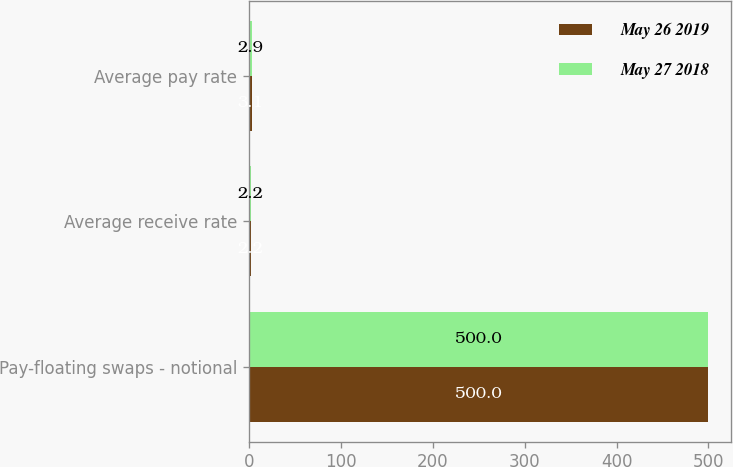Convert chart to OTSL. <chart><loc_0><loc_0><loc_500><loc_500><stacked_bar_chart><ecel><fcel>Pay-floating swaps - notional<fcel>Average receive rate<fcel>Average pay rate<nl><fcel>May 26 2019<fcel>500<fcel>2.2<fcel>3.1<nl><fcel>May 27 2018<fcel>500<fcel>2.2<fcel>2.9<nl></chart> 